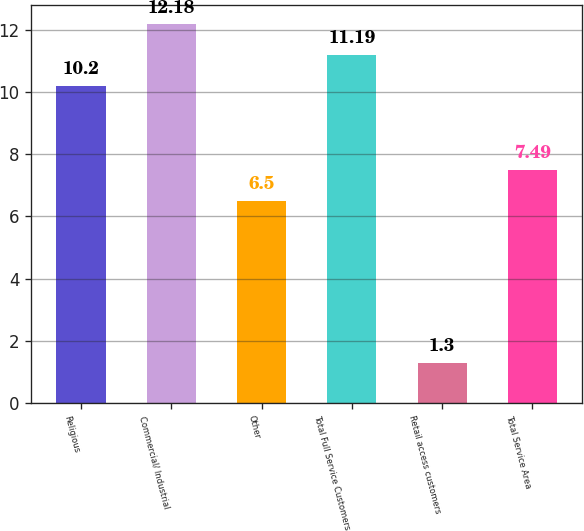Convert chart to OTSL. <chart><loc_0><loc_0><loc_500><loc_500><bar_chart><fcel>Religious<fcel>Commercial/ Industrial<fcel>Other<fcel>Total Full Service Customers<fcel>Retail access customers<fcel>Total Service Area<nl><fcel>10.2<fcel>12.18<fcel>6.5<fcel>11.19<fcel>1.3<fcel>7.49<nl></chart> 